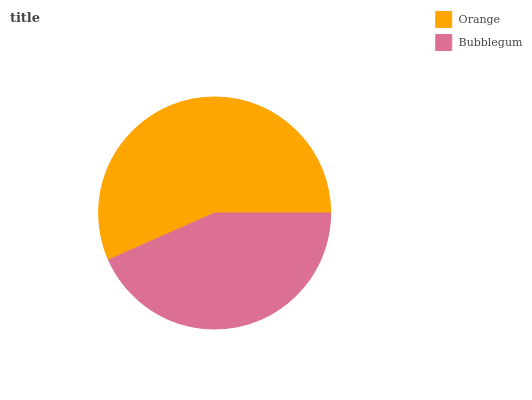Is Bubblegum the minimum?
Answer yes or no. Yes. Is Orange the maximum?
Answer yes or no. Yes. Is Bubblegum the maximum?
Answer yes or no. No. Is Orange greater than Bubblegum?
Answer yes or no. Yes. Is Bubblegum less than Orange?
Answer yes or no. Yes. Is Bubblegum greater than Orange?
Answer yes or no. No. Is Orange less than Bubblegum?
Answer yes or no. No. Is Orange the high median?
Answer yes or no. Yes. Is Bubblegum the low median?
Answer yes or no. Yes. Is Bubblegum the high median?
Answer yes or no. No. Is Orange the low median?
Answer yes or no. No. 